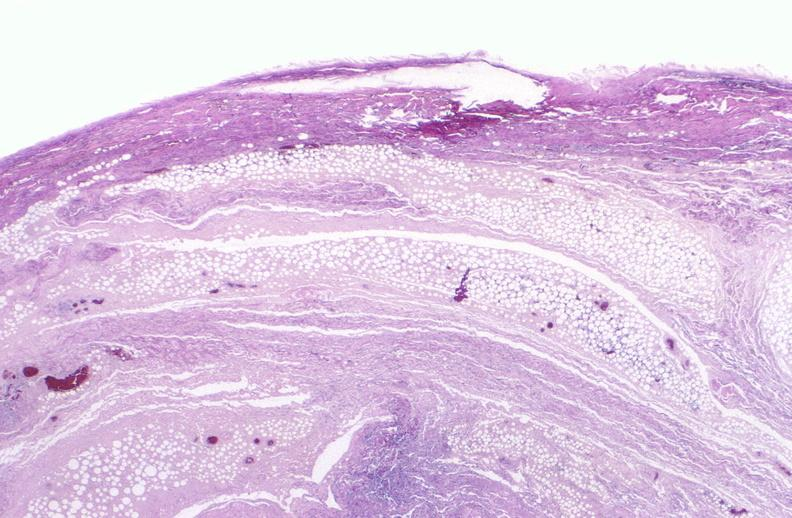where is this?
Answer the question using a single word or phrase. Skin 